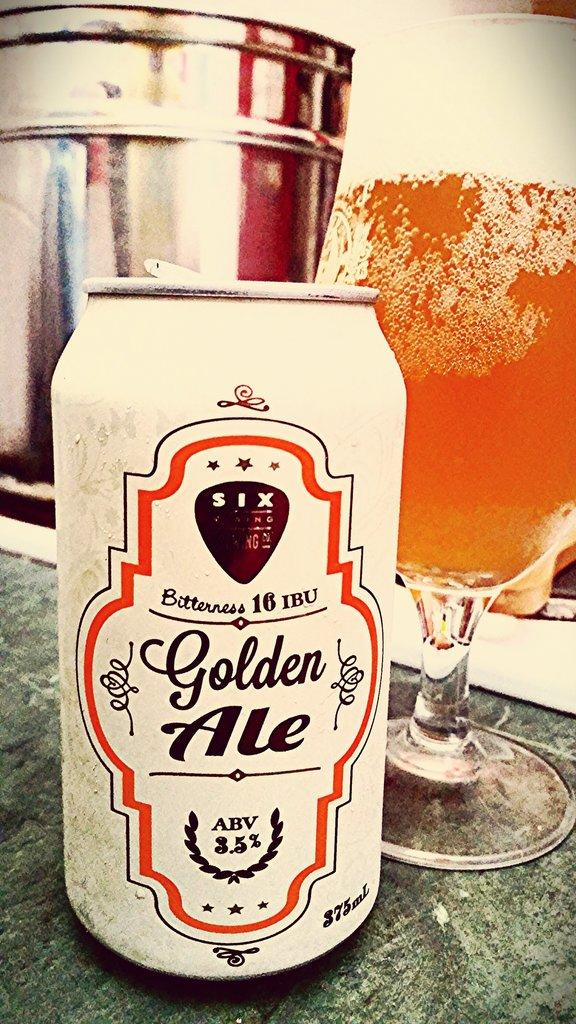<image>
Summarize the visual content of the image. Bitterness 16 IBU Golden Ale positioned next to a beer glass with a perfect pour. 